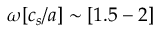<formula> <loc_0><loc_0><loc_500><loc_500>\omega [ c _ { s } / a ] \sim [ 1 . 5 - 2 ]</formula> 